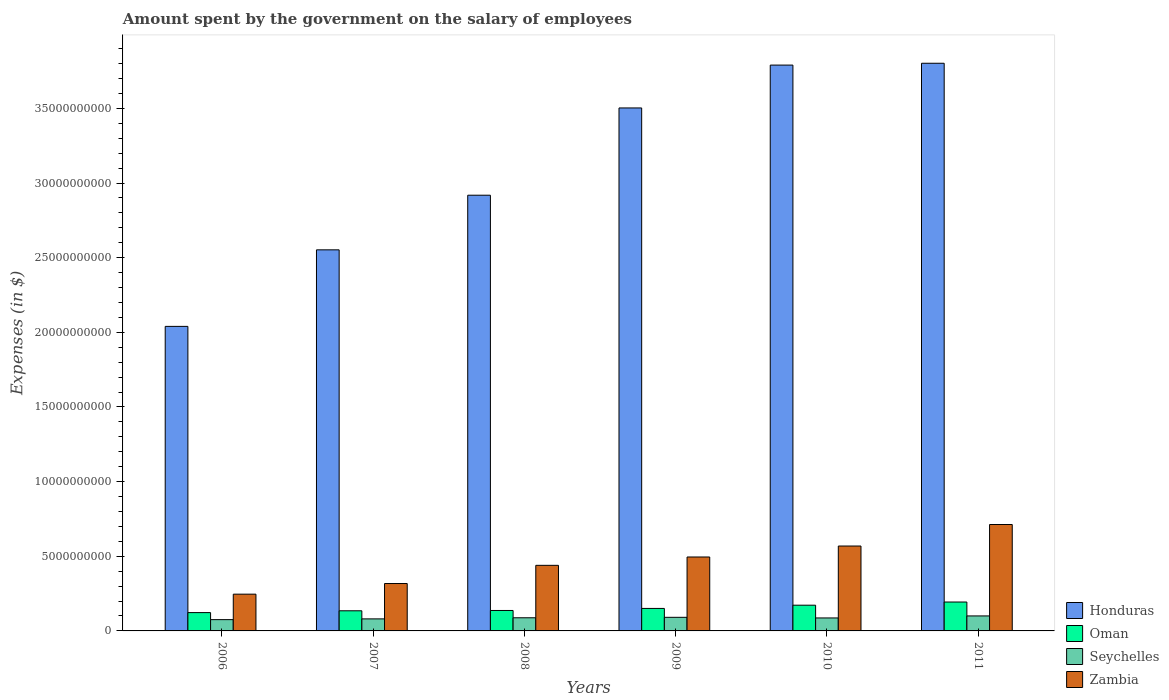How many different coloured bars are there?
Offer a very short reply. 4. Are the number of bars per tick equal to the number of legend labels?
Make the answer very short. Yes. Are the number of bars on each tick of the X-axis equal?
Provide a short and direct response. Yes. What is the amount spent on the salary of employees by the government in Oman in 2007?
Your answer should be compact. 1.35e+09. Across all years, what is the maximum amount spent on the salary of employees by the government in Zambia?
Your response must be concise. 7.13e+09. Across all years, what is the minimum amount spent on the salary of employees by the government in Seychelles?
Provide a short and direct response. 7.56e+08. In which year was the amount spent on the salary of employees by the government in Oman minimum?
Provide a short and direct response. 2006. What is the total amount spent on the salary of employees by the government in Seychelles in the graph?
Keep it short and to the point. 5.23e+09. What is the difference between the amount spent on the salary of employees by the government in Honduras in 2008 and that in 2011?
Keep it short and to the point. -8.84e+09. What is the difference between the amount spent on the salary of employees by the government in Oman in 2007 and the amount spent on the salary of employees by the government in Seychelles in 2010?
Give a very brief answer. 4.79e+08. What is the average amount spent on the salary of employees by the government in Seychelles per year?
Give a very brief answer. 8.71e+08. In the year 2008, what is the difference between the amount spent on the salary of employees by the government in Seychelles and amount spent on the salary of employees by the government in Oman?
Keep it short and to the point. -4.88e+08. What is the ratio of the amount spent on the salary of employees by the government in Zambia in 2008 to that in 2011?
Your answer should be compact. 0.62. Is the difference between the amount spent on the salary of employees by the government in Seychelles in 2009 and 2010 greater than the difference between the amount spent on the salary of employees by the government in Oman in 2009 and 2010?
Keep it short and to the point. Yes. What is the difference between the highest and the second highest amount spent on the salary of employees by the government in Zambia?
Provide a succinct answer. 1.44e+09. What is the difference between the highest and the lowest amount spent on the salary of employees by the government in Oman?
Ensure brevity in your answer.  7.08e+08. In how many years, is the amount spent on the salary of employees by the government in Oman greater than the average amount spent on the salary of employees by the government in Oman taken over all years?
Your answer should be compact. 2. Is it the case that in every year, the sum of the amount spent on the salary of employees by the government in Zambia and amount spent on the salary of employees by the government in Honduras is greater than the sum of amount spent on the salary of employees by the government in Seychelles and amount spent on the salary of employees by the government in Oman?
Your answer should be compact. Yes. What does the 4th bar from the left in 2006 represents?
Make the answer very short. Zambia. What does the 1st bar from the right in 2009 represents?
Keep it short and to the point. Zambia. Is it the case that in every year, the sum of the amount spent on the salary of employees by the government in Honduras and amount spent on the salary of employees by the government in Zambia is greater than the amount spent on the salary of employees by the government in Seychelles?
Offer a very short reply. Yes. Are all the bars in the graph horizontal?
Offer a terse response. No. How many years are there in the graph?
Provide a short and direct response. 6. What is the difference between two consecutive major ticks on the Y-axis?
Provide a short and direct response. 5.00e+09. Does the graph contain grids?
Make the answer very short. No. What is the title of the graph?
Give a very brief answer. Amount spent by the government on the salary of employees. Does "Kyrgyz Republic" appear as one of the legend labels in the graph?
Provide a short and direct response. No. What is the label or title of the Y-axis?
Make the answer very short. Expenses (in $). What is the Expenses (in $) of Honduras in 2006?
Offer a terse response. 2.04e+1. What is the Expenses (in $) of Oman in 2006?
Ensure brevity in your answer.  1.23e+09. What is the Expenses (in $) of Seychelles in 2006?
Keep it short and to the point. 7.56e+08. What is the Expenses (in $) in Zambia in 2006?
Keep it short and to the point. 2.46e+09. What is the Expenses (in $) of Honduras in 2007?
Ensure brevity in your answer.  2.55e+1. What is the Expenses (in $) in Oman in 2007?
Provide a short and direct response. 1.35e+09. What is the Expenses (in $) in Seychelles in 2007?
Your answer should be very brief. 8.06e+08. What is the Expenses (in $) of Zambia in 2007?
Provide a succinct answer. 3.17e+09. What is the Expenses (in $) of Honduras in 2008?
Make the answer very short. 2.92e+1. What is the Expenses (in $) of Oman in 2008?
Your response must be concise. 1.37e+09. What is the Expenses (in $) of Seychelles in 2008?
Your response must be concise. 8.81e+08. What is the Expenses (in $) in Zambia in 2008?
Ensure brevity in your answer.  4.39e+09. What is the Expenses (in $) in Honduras in 2009?
Provide a succinct answer. 3.50e+1. What is the Expenses (in $) of Oman in 2009?
Make the answer very short. 1.51e+09. What is the Expenses (in $) of Seychelles in 2009?
Offer a terse response. 9.11e+08. What is the Expenses (in $) of Zambia in 2009?
Give a very brief answer. 4.95e+09. What is the Expenses (in $) of Honduras in 2010?
Provide a succinct answer. 3.79e+1. What is the Expenses (in $) in Oman in 2010?
Your response must be concise. 1.72e+09. What is the Expenses (in $) of Seychelles in 2010?
Your answer should be very brief. 8.69e+08. What is the Expenses (in $) in Zambia in 2010?
Give a very brief answer. 5.69e+09. What is the Expenses (in $) of Honduras in 2011?
Offer a very short reply. 3.80e+1. What is the Expenses (in $) of Oman in 2011?
Your response must be concise. 1.94e+09. What is the Expenses (in $) of Seychelles in 2011?
Offer a terse response. 1.00e+09. What is the Expenses (in $) of Zambia in 2011?
Give a very brief answer. 7.13e+09. Across all years, what is the maximum Expenses (in $) of Honduras?
Ensure brevity in your answer.  3.80e+1. Across all years, what is the maximum Expenses (in $) of Oman?
Give a very brief answer. 1.94e+09. Across all years, what is the maximum Expenses (in $) in Seychelles?
Your answer should be very brief. 1.00e+09. Across all years, what is the maximum Expenses (in $) of Zambia?
Offer a terse response. 7.13e+09. Across all years, what is the minimum Expenses (in $) in Honduras?
Your answer should be compact. 2.04e+1. Across all years, what is the minimum Expenses (in $) in Oman?
Your response must be concise. 1.23e+09. Across all years, what is the minimum Expenses (in $) of Seychelles?
Give a very brief answer. 7.56e+08. Across all years, what is the minimum Expenses (in $) in Zambia?
Give a very brief answer. 2.46e+09. What is the total Expenses (in $) of Honduras in the graph?
Offer a terse response. 1.86e+11. What is the total Expenses (in $) in Oman in the graph?
Your response must be concise. 9.11e+09. What is the total Expenses (in $) of Seychelles in the graph?
Provide a short and direct response. 5.23e+09. What is the total Expenses (in $) of Zambia in the graph?
Keep it short and to the point. 2.78e+1. What is the difference between the Expenses (in $) in Honduras in 2006 and that in 2007?
Provide a succinct answer. -5.13e+09. What is the difference between the Expenses (in $) in Oman in 2006 and that in 2007?
Provide a short and direct response. -1.20e+08. What is the difference between the Expenses (in $) of Seychelles in 2006 and that in 2007?
Make the answer very short. -4.97e+07. What is the difference between the Expenses (in $) of Zambia in 2006 and that in 2007?
Your answer should be compact. -7.12e+08. What is the difference between the Expenses (in $) of Honduras in 2006 and that in 2008?
Offer a terse response. -8.79e+09. What is the difference between the Expenses (in $) of Oman in 2006 and that in 2008?
Provide a short and direct response. -1.42e+08. What is the difference between the Expenses (in $) of Seychelles in 2006 and that in 2008?
Offer a terse response. -1.25e+08. What is the difference between the Expenses (in $) in Zambia in 2006 and that in 2008?
Your response must be concise. -1.93e+09. What is the difference between the Expenses (in $) of Honduras in 2006 and that in 2009?
Ensure brevity in your answer.  -1.46e+1. What is the difference between the Expenses (in $) in Oman in 2006 and that in 2009?
Provide a succinct answer. -2.79e+08. What is the difference between the Expenses (in $) of Seychelles in 2006 and that in 2009?
Keep it short and to the point. -1.55e+08. What is the difference between the Expenses (in $) in Zambia in 2006 and that in 2009?
Your answer should be compact. -2.49e+09. What is the difference between the Expenses (in $) in Honduras in 2006 and that in 2010?
Keep it short and to the point. -1.75e+1. What is the difference between the Expenses (in $) in Oman in 2006 and that in 2010?
Keep it short and to the point. -4.95e+08. What is the difference between the Expenses (in $) in Seychelles in 2006 and that in 2010?
Keep it short and to the point. -1.12e+08. What is the difference between the Expenses (in $) in Zambia in 2006 and that in 2010?
Your response must be concise. -3.22e+09. What is the difference between the Expenses (in $) of Honduras in 2006 and that in 2011?
Offer a very short reply. -1.76e+1. What is the difference between the Expenses (in $) in Oman in 2006 and that in 2011?
Your response must be concise. -7.08e+08. What is the difference between the Expenses (in $) of Seychelles in 2006 and that in 2011?
Keep it short and to the point. -2.48e+08. What is the difference between the Expenses (in $) of Zambia in 2006 and that in 2011?
Your response must be concise. -4.67e+09. What is the difference between the Expenses (in $) of Honduras in 2007 and that in 2008?
Keep it short and to the point. -3.66e+09. What is the difference between the Expenses (in $) in Oman in 2007 and that in 2008?
Offer a very short reply. -2.13e+07. What is the difference between the Expenses (in $) in Seychelles in 2007 and that in 2008?
Keep it short and to the point. -7.49e+07. What is the difference between the Expenses (in $) of Zambia in 2007 and that in 2008?
Provide a short and direct response. -1.22e+09. What is the difference between the Expenses (in $) of Honduras in 2007 and that in 2009?
Your answer should be very brief. -9.50e+09. What is the difference between the Expenses (in $) of Oman in 2007 and that in 2009?
Provide a short and direct response. -1.59e+08. What is the difference between the Expenses (in $) of Seychelles in 2007 and that in 2009?
Make the answer very short. -1.05e+08. What is the difference between the Expenses (in $) of Zambia in 2007 and that in 2009?
Your answer should be compact. -1.78e+09. What is the difference between the Expenses (in $) of Honduras in 2007 and that in 2010?
Ensure brevity in your answer.  -1.24e+1. What is the difference between the Expenses (in $) in Oman in 2007 and that in 2010?
Provide a succinct answer. -3.75e+08. What is the difference between the Expenses (in $) in Seychelles in 2007 and that in 2010?
Provide a succinct answer. -6.27e+07. What is the difference between the Expenses (in $) in Zambia in 2007 and that in 2010?
Your response must be concise. -2.51e+09. What is the difference between the Expenses (in $) in Honduras in 2007 and that in 2011?
Offer a very short reply. -1.25e+1. What is the difference between the Expenses (in $) in Oman in 2007 and that in 2011?
Keep it short and to the point. -5.88e+08. What is the difference between the Expenses (in $) of Seychelles in 2007 and that in 2011?
Provide a succinct answer. -1.99e+08. What is the difference between the Expenses (in $) of Zambia in 2007 and that in 2011?
Make the answer very short. -3.95e+09. What is the difference between the Expenses (in $) of Honduras in 2008 and that in 2009?
Your response must be concise. -5.85e+09. What is the difference between the Expenses (in $) in Oman in 2008 and that in 2009?
Your answer should be very brief. -1.37e+08. What is the difference between the Expenses (in $) in Seychelles in 2008 and that in 2009?
Keep it short and to the point. -3.04e+07. What is the difference between the Expenses (in $) of Zambia in 2008 and that in 2009?
Provide a short and direct response. -5.59e+08. What is the difference between the Expenses (in $) of Honduras in 2008 and that in 2010?
Keep it short and to the point. -8.72e+09. What is the difference between the Expenses (in $) of Oman in 2008 and that in 2010?
Provide a succinct answer. -3.54e+08. What is the difference between the Expenses (in $) of Seychelles in 2008 and that in 2010?
Provide a succinct answer. 1.22e+07. What is the difference between the Expenses (in $) of Zambia in 2008 and that in 2010?
Provide a short and direct response. -1.29e+09. What is the difference between the Expenses (in $) of Honduras in 2008 and that in 2011?
Keep it short and to the point. -8.84e+09. What is the difference between the Expenses (in $) of Oman in 2008 and that in 2011?
Provide a short and direct response. -5.66e+08. What is the difference between the Expenses (in $) in Seychelles in 2008 and that in 2011?
Offer a very short reply. -1.24e+08. What is the difference between the Expenses (in $) in Zambia in 2008 and that in 2011?
Provide a succinct answer. -2.73e+09. What is the difference between the Expenses (in $) of Honduras in 2009 and that in 2010?
Your response must be concise. -2.87e+09. What is the difference between the Expenses (in $) in Oman in 2009 and that in 2010?
Give a very brief answer. -2.16e+08. What is the difference between the Expenses (in $) in Seychelles in 2009 and that in 2010?
Offer a very short reply. 4.27e+07. What is the difference between the Expenses (in $) of Zambia in 2009 and that in 2010?
Ensure brevity in your answer.  -7.35e+08. What is the difference between the Expenses (in $) in Honduras in 2009 and that in 2011?
Your answer should be very brief. -2.99e+09. What is the difference between the Expenses (in $) of Oman in 2009 and that in 2011?
Give a very brief answer. -4.29e+08. What is the difference between the Expenses (in $) of Seychelles in 2009 and that in 2011?
Your answer should be very brief. -9.33e+07. What is the difference between the Expenses (in $) of Zambia in 2009 and that in 2011?
Your response must be concise. -2.18e+09. What is the difference between the Expenses (in $) in Honduras in 2010 and that in 2011?
Your answer should be very brief. -1.22e+08. What is the difference between the Expenses (in $) in Oman in 2010 and that in 2011?
Offer a terse response. -2.13e+08. What is the difference between the Expenses (in $) in Seychelles in 2010 and that in 2011?
Give a very brief answer. -1.36e+08. What is the difference between the Expenses (in $) of Zambia in 2010 and that in 2011?
Your answer should be very brief. -1.44e+09. What is the difference between the Expenses (in $) of Honduras in 2006 and the Expenses (in $) of Oman in 2007?
Your answer should be compact. 1.90e+1. What is the difference between the Expenses (in $) of Honduras in 2006 and the Expenses (in $) of Seychelles in 2007?
Make the answer very short. 1.96e+1. What is the difference between the Expenses (in $) of Honduras in 2006 and the Expenses (in $) of Zambia in 2007?
Your answer should be compact. 1.72e+1. What is the difference between the Expenses (in $) of Oman in 2006 and the Expenses (in $) of Seychelles in 2007?
Make the answer very short. 4.22e+08. What is the difference between the Expenses (in $) in Oman in 2006 and the Expenses (in $) in Zambia in 2007?
Provide a short and direct response. -1.95e+09. What is the difference between the Expenses (in $) of Seychelles in 2006 and the Expenses (in $) of Zambia in 2007?
Provide a short and direct response. -2.42e+09. What is the difference between the Expenses (in $) of Honduras in 2006 and the Expenses (in $) of Oman in 2008?
Your answer should be compact. 1.90e+1. What is the difference between the Expenses (in $) of Honduras in 2006 and the Expenses (in $) of Seychelles in 2008?
Make the answer very short. 1.95e+1. What is the difference between the Expenses (in $) in Honduras in 2006 and the Expenses (in $) in Zambia in 2008?
Provide a succinct answer. 1.60e+1. What is the difference between the Expenses (in $) of Oman in 2006 and the Expenses (in $) of Seychelles in 2008?
Give a very brief answer. 3.47e+08. What is the difference between the Expenses (in $) in Oman in 2006 and the Expenses (in $) in Zambia in 2008?
Make the answer very short. -3.17e+09. What is the difference between the Expenses (in $) in Seychelles in 2006 and the Expenses (in $) in Zambia in 2008?
Your response must be concise. -3.64e+09. What is the difference between the Expenses (in $) in Honduras in 2006 and the Expenses (in $) in Oman in 2009?
Keep it short and to the point. 1.89e+1. What is the difference between the Expenses (in $) in Honduras in 2006 and the Expenses (in $) in Seychelles in 2009?
Give a very brief answer. 1.95e+1. What is the difference between the Expenses (in $) in Honduras in 2006 and the Expenses (in $) in Zambia in 2009?
Provide a short and direct response. 1.54e+1. What is the difference between the Expenses (in $) in Oman in 2006 and the Expenses (in $) in Seychelles in 2009?
Your answer should be compact. 3.16e+08. What is the difference between the Expenses (in $) in Oman in 2006 and the Expenses (in $) in Zambia in 2009?
Provide a succinct answer. -3.72e+09. What is the difference between the Expenses (in $) of Seychelles in 2006 and the Expenses (in $) of Zambia in 2009?
Your answer should be compact. -4.19e+09. What is the difference between the Expenses (in $) of Honduras in 2006 and the Expenses (in $) of Oman in 2010?
Provide a short and direct response. 1.87e+1. What is the difference between the Expenses (in $) in Honduras in 2006 and the Expenses (in $) in Seychelles in 2010?
Offer a terse response. 1.95e+1. What is the difference between the Expenses (in $) in Honduras in 2006 and the Expenses (in $) in Zambia in 2010?
Offer a terse response. 1.47e+1. What is the difference between the Expenses (in $) in Oman in 2006 and the Expenses (in $) in Seychelles in 2010?
Give a very brief answer. 3.59e+08. What is the difference between the Expenses (in $) in Oman in 2006 and the Expenses (in $) in Zambia in 2010?
Offer a terse response. -4.46e+09. What is the difference between the Expenses (in $) of Seychelles in 2006 and the Expenses (in $) of Zambia in 2010?
Keep it short and to the point. -4.93e+09. What is the difference between the Expenses (in $) in Honduras in 2006 and the Expenses (in $) in Oman in 2011?
Give a very brief answer. 1.85e+1. What is the difference between the Expenses (in $) of Honduras in 2006 and the Expenses (in $) of Seychelles in 2011?
Provide a succinct answer. 1.94e+1. What is the difference between the Expenses (in $) of Honduras in 2006 and the Expenses (in $) of Zambia in 2011?
Your answer should be very brief. 1.33e+1. What is the difference between the Expenses (in $) in Oman in 2006 and the Expenses (in $) in Seychelles in 2011?
Offer a very short reply. 2.23e+08. What is the difference between the Expenses (in $) in Oman in 2006 and the Expenses (in $) in Zambia in 2011?
Your response must be concise. -5.90e+09. What is the difference between the Expenses (in $) of Seychelles in 2006 and the Expenses (in $) of Zambia in 2011?
Your answer should be very brief. -6.37e+09. What is the difference between the Expenses (in $) in Honduras in 2007 and the Expenses (in $) in Oman in 2008?
Offer a very short reply. 2.42e+1. What is the difference between the Expenses (in $) of Honduras in 2007 and the Expenses (in $) of Seychelles in 2008?
Your answer should be compact. 2.46e+1. What is the difference between the Expenses (in $) of Honduras in 2007 and the Expenses (in $) of Zambia in 2008?
Ensure brevity in your answer.  2.11e+1. What is the difference between the Expenses (in $) in Oman in 2007 and the Expenses (in $) in Seychelles in 2008?
Ensure brevity in your answer.  4.67e+08. What is the difference between the Expenses (in $) of Oman in 2007 and the Expenses (in $) of Zambia in 2008?
Ensure brevity in your answer.  -3.04e+09. What is the difference between the Expenses (in $) of Seychelles in 2007 and the Expenses (in $) of Zambia in 2008?
Provide a short and direct response. -3.59e+09. What is the difference between the Expenses (in $) in Honduras in 2007 and the Expenses (in $) in Oman in 2009?
Your response must be concise. 2.40e+1. What is the difference between the Expenses (in $) in Honduras in 2007 and the Expenses (in $) in Seychelles in 2009?
Make the answer very short. 2.46e+1. What is the difference between the Expenses (in $) of Honduras in 2007 and the Expenses (in $) of Zambia in 2009?
Keep it short and to the point. 2.06e+1. What is the difference between the Expenses (in $) of Oman in 2007 and the Expenses (in $) of Seychelles in 2009?
Your response must be concise. 4.37e+08. What is the difference between the Expenses (in $) of Oman in 2007 and the Expenses (in $) of Zambia in 2009?
Make the answer very short. -3.60e+09. What is the difference between the Expenses (in $) of Seychelles in 2007 and the Expenses (in $) of Zambia in 2009?
Provide a succinct answer. -4.15e+09. What is the difference between the Expenses (in $) of Honduras in 2007 and the Expenses (in $) of Oman in 2010?
Offer a very short reply. 2.38e+1. What is the difference between the Expenses (in $) in Honduras in 2007 and the Expenses (in $) in Seychelles in 2010?
Make the answer very short. 2.47e+1. What is the difference between the Expenses (in $) of Honduras in 2007 and the Expenses (in $) of Zambia in 2010?
Keep it short and to the point. 1.98e+1. What is the difference between the Expenses (in $) of Oman in 2007 and the Expenses (in $) of Seychelles in 2010?
Offer a very short reply. 4.79e+08. What is the difference between the Expenses (in $) in Oman in 2007 and the Expenses (in $) in Zambia in 2010?
Ensure brevity in your answer.  -4.34e+09. What is the difference between the Expenses (in $) of Seychelles in 2007 and the Expenses (in $) of Zambia in 2010?
Give a very brief answer. -4.88e+09. What is the difference between the Expenses (in $) in Honduras in 2007 and the Expenses (in $) in Oman in 2011?
Your response must be concise. 2.36e+1. What is the difference between the Expenses (in $) of Honduras in 2007 and the Expenses (in $) of Seychelles in 2011?
Your response must be concise. 2.45e+1. What is the difference between the Expenses (in $) in Honduras in 2007 and the Expenses (in $) in Zambia in 2011?
Offer a terse response. 1.84e+1. What is the difference between the Expenses (in $) in Oman in 2007 and the Expenses (in $) in Seychelles in 2011?
Your response must be concise. 3.43e+08. What is the difference between the Expenses (in $) in Oman in 2007 and the Expenses (in $) in Zambia in 2011?
Your answer should be very brief. -5.78e+09. What is the difference between the Expenses (in $) of Seychelles in 2007 and the Expenses (in $) of Zambia in 2011?
Your answer should be very brief. -6.32e+09. What is the difference between the Expenses (in $) of Honduras in 2008 and the Expenses (in $) of Oman in 2009?
Keep it short and to the point. 2.77e+1. What is the difference between the Expenses (in $) in Honduras in 2008 and the Expenses (in $) in Seychelles in 2009?
Keep it short and to the point. 2.83e+1. What is the difference between the Expenses (in $) in Honduras in 2008 and the Expenses (in $) in Zambia in 2009?
Make the answer very short. 2.42e+1. What is the difference between the Expenses (in $) of Oman in 2008 and the Expenses (in $) of Seychelles in 2009?
Ensure brevity in your answer.  4.58e+08. What is the difference between the Expenses (in $) in Oman in 2008 and the Expenses (in $) in Zambia in 2009?
Ensure brevity in your answer.  -3.58e+09. What is the difference between the Expenses (in $) of Seychelles in 2008 and the Expenses (in $) of Zambia in 2009?
Provide a succinct answer. -4.07e+09. What is the difference between the Expenses (in $) of Honduras in 2008 and the Expenses (in $) of Oman in 2010?
Your response must be concise. 2.75e+1. What is the difference between the Expenses (in $) in Honduras in 2008 and the Expenses (in $) in Seychelles in 2010?
Offer a terse response. 2.83e+1. What is the difference between the Expenses (in $) of Honduras in 2008 and the Expenses (in $) of Zambia in 2010?
Provide a succinct answer. 2.35e+1. What is the difference between the Expenses (in $) of Oman in 2008 and the Expenses (in $) of Seychelles in 2010?
Keep it short and to the point. 5.01e+08. What is the difference between the Expenses (in $) in Oman in 2008 and the Expenses (in $) in Zambia in 2010?
Give a very brief answer. -4.32e+09. What is the difference between the Expenses (in $) of Seychelles in 2008 and the Expenses (in $) of Zambia in 2010?
Your response must be concise. -4.81e+09. What is the difference between the Expenses (in $) in Honduras in 2008 and the Expenses (in $) in Oman in 2011?
Ensure brevity in your answer.  2.72e+1. What is the difference between the Expenses (in $) of Honduras in 2008 and the Expenses (in $) of Seychelles in 2011?
Provide a succinct answer. 2.82e+1. What is the difference between the Expenses (in $) in Honduras in 2008 and the Expenses (in $) in Zambia in 2011?
Your answer should be compact. 2.21e+1. What is the difference between the Expenses (in $) in Oman in 2008 and the Expenses (in $) in Seychelles in 2011?
Offer a very short reply. 3.65e+08. What is the difference between the Expenses (in $) of Oman in 2008 and the Expenses (in $) of Zambia in 2011?
Provide a succinct answer. -5.76e+09. What is the difference between the Expenses (in $) of Seychelles in 2008 and the Expenses (in $) of Zambia in 2011?
Provide a short and direct response. -6.25e+09. What is the difference between the Expenses (in $) in Honduras in 2009 and the Expenses (in $) in Oman in 2010?
Your answer should be compact. 3.33e+1. What is the difference between the Expenses (in $) in Honduras in 2009 and the Expenses (in $) in Seychelles in 2010?
Your answer should be very brief. 3.42e+1. What is the difference between the Expenses (in $) in Honduras in 2009 and the Expenses (in $) in Zambia in 2010?
Ensure brevity in your answer.  2.93e+1. What is the difference between the Expenses (in $) in Oman in 2009 and the Expenses (in $) in Seychelles in 2010?
Your answer should be compact. 6.38e+08. What is the difference between the Expenses (in $) in Oman in 2009 and the Expenses (in $) in Zambia in 2010?
Your response must be concise. -4.18e+09. What is the difference between the Expenses (in $) in Seychelles in 2009 and the Expenses (in $) in Zambia in 2010?
Ensure brevity in your answer.  -4.77e+09. What is the difference between the Expenses (in $) of Honduras in 2009 and the Expenses (in $) of Oman in 2011?
Your response must be concise. 3.31e+1. What is the difference between the Expenses (in $) in Honduras in 2009 and the Expenses (in $) in Seychelles in 2011?
Keep it short and to the point. 3.40e+1. What is the difference between the Expenses (in $) of Honduras in 2009 and the Expenses (in $) of Zambia in 2011?
Provide a short and direct response. 2.79e+1. What is the difference between the Expenses (in $) in Oman in 2009 and the Expenses (in $) in Seychelles in 2011?
Your answer should be compact. 5.02e+08. What is the difference between the Expenses (in $) of Oman in 2009 and the Expenses (in $) of Zambia in 2011?
Make the answer very short. -5.62e+09. What is the difference between the Expenses (in $) of Seychelles in 2009 and the Expenses (in $) of Zambia in 2011?
Offer a very short reply. -6.22e+09. What is the difference between the Expenses (in $) in Honduras in 2010 and the Expenses (in $) in Oman in 2011?
Keep it short and to the point. 3.60e+1. What is the difference between the Expenses (in $) in Honduras in 2010 and the Expenses (in $) in Seychelles in 2011?
Provide a short and direct response. 3.69e+1. What is the difference between the Expenses (in $) of Honduras in 2010 and the Expenses (in $) of Zambia in 2011?
Make the answer very short. 3.08e+1. What is the difference between the Expenses (in $) in Oman in 2010 and the Expenses (in $) in Seychelles in 2011?
Make the answer very short. 7.18e+08. What is the difference between the Expenses (in $) in Oman in 2010 and the Expenses (in $) in Zambia in 2011?
Provide a succinct answer. -5.40e+09. What is the difference between the Expenses (in $) of Seychelles in 2010 and the Expenses (in $) of Zambia in 2011?
Provide a short and direct response. -6.26e+09. What is the average Expenses (in $) in Honduras per year?
Your answer should be very brief. 3.10e+1. What is the average Expenses (in $) in Oman per year?
Ensure brevity in your answer.  1.52e+09. What is the average Expenses (in $) of Seychelles per year?
Offer a very short reply. 8.71e+08. What is the average Expenses (in $) in Zambia per year?
Your answer should be very brief. 4.63e+09. In the year 2006, what is the difference between the Expenses (in $) in Honduras and Expenses (in $) in Oman?
Your response must be concise. 1.92e+1. In the year 2006, what is the difference between the Expenses (in $) in Honduras and Expenses (in $) in Seychelles?
Offer a very short reply. 1.96e+1. In the year 2006, what is the difference between the Expenses (in $) of Honduras and Expenses (in $) of Zambia?
Your answer should be very brief. 1.79e+1. In the year 2006, what is the difference between the Expenses (in $) of Oman and Expenses (in $) of Seychelles?
Keep it short and to the point. 4.71e+08. In the year 2006, what is the difference between the Expenses (in $) of Oman and Expenses (in $) of Zambia?
Your answer should be compact. -1.23e+09. In the year 2006, what is the difference between the Expenses (in $) of Seychelles and Expenses (in $) of Zambia?
Offer a very short reply. -1.71e+09. In the year 2007, what is the difference between the Expenses (in $) in Honduras and Expenses (in $) in Oman?
Keep it short and to the point. 2.42e+1. In the year 2007, what is the difference between the Expenses (in $) in Honduras and Expenses (in $) in Seychelles?
Your response must be concise. 2.47e+1. In the year 2007, what is the difference between the Expenses (in $) of Honduras and Expenses (in $) of Zambia?
Ensure brevity in your answer.  2.23e+1. In the year 2007, what is the difference between the Expenses (in $) in Oman and Expenses (in $) in Seychelles?
Provide a succinct answer. 5.42e+08. In the year 2007, what is the difference between the Expenses (in $) of Oman and Expenses (in $) of Zambia?
Your response must be concise. -1.83e+09. In the year 2007, what is the difference between the Expenses (in $) of Seychelles and Expenses (in $) of Zambia?
Make the answer very short. -2.37e+09. In the year 2008, what is the difference between the Expenses (in $) of Honduras and Expenses (in $) of Oman?
Make the answer very short. 2.78e+1. In the year 2008, what is the difference between the Expenses (in $) of Honduras and Expenses (in $) of Seychelles?
Keep it short and to the point. 2.83e+1. In the year 2008, what is the difference between the Expenses (in $) of Honduras and Expenses (in $) of Zambia?
Provide a succinct answer. 2.48e+1. In the year 2008, what is the difference between the Expenses (in $) of Oman and Expenses (in $) of Seychelles?
Offer a very short reply. 4.88e+08. In the year 2008, what is the difference between the Expenses (in $) in Oman and Expenses (in $) in Zambia?
Your response must be concise. -3.02e+09. In the year 2008, what is the difference between the Expenses (in $) of Seychelles and Expenses (in $) of Zambia?
Your answer should be very brief. -3.51e+09. In the year 2009, what is the difference between the Expenses (in $) in Honduras and Expenses (in $) in Oman?
Your answer should be compact. 3.35e+1. In the year 2009, what is the difference between the Expenses (in $) in Honduras and Expenses (in $) in Seychelles?
Give a very brief answer. 3.41e+1. In the year 2009, what is the difference between the Expenses (in $) in Honduras and Expenses (in $) in Zambia?
Your answer should be compact. 3.01e+1. In the year 2009, what is the difference between the Expenses (in $) in Oman and Expenses (in $) in Seychelles?
Your answer should be compact. 5.95e+08. In the year 2009, what is the difference between the Expenses (in $) of Oman and Expenses (in $) of Zambia?
Ensure brevity in your answer.  -3.44e+09. In the year 2009, what is the difference between the Expenses (in $) in Seychelles and Expenses (in $) in Zambia?
Offer a very short reply. -4.04e+09. In the year 2010, what is the difference between the Expenses (in $) of Honduras and Expenses (in $) of Oman?
Your answer should be compact. 3.62e+1. In the year 2010, what is the difference between the Expenses (in $) in Honduras and Expenses (in $) in Seychelles?
Give a very brief answer. 3.70e+1. In the year 2010, what is the difference between the Expenses (in $) of Honduras and Expenses (in $) of Zambia?
Offer a very short reply. 3.22e+1. In the year 2010, what is the difference between the Expenses (in $) of Oman and Expenses (in $) of Seychelles?
Your answer should be compact. 8.54e+08. In the year 2010, what is the difference between the Expenses (in $) in Oman and Expenses (in $) in Zambia?
Provide a short and direct response. -3.96e+09. In the year 2010, what is the difference between the Expenses (in $) in Seychelles and Expenses (in $) in Zambia?
Provide a succinct answer. -4.82e+09. In the year 2011, what is the difference between the Expenses (in $) of Honduras and Expenses (in $) of Oman?
Your answer should be compact. 3.61e+1. In the year 2011, what is the difference between the Expenses (in $) in Honduras and Expenses (in $) in Seychelles?
Make the answer very short. 3.70e+1. In the year 2011, what is the difference between the Expenses (in $) of Honduras and Expenses (in $) of Zambia?
Make the answer very short. 3.09e+1. In the year 2011, what is the difference between the Expenses (in $) of Oman and Expenses (in $) of Seychelles?
Your answer should be very brief. 9.31e+08. In the year 2011, what is the difference between the Expenses (in $) of Oman and Expenses (in $) of Zambia?
Provide a succinct answer. -5.19e+09. In the year 2011, what is the difference between the Expenses (in $) in Seychelles and Expenses (in $) in Zambia?
Offer a very short reply. -6.12e+09. What is the ratio of the Expenses (in $) of Honduras in 2006 to that in 2007?
Ensure brevity in your answer.  0.8. What is the ratio of the Expenses (in $) in Oman in 2006 to that in 2007?
Offer a very short reply. 0.91. What is the ratio of the Expenses (in $) in Seychelles in 2006 to that in 2007?
Give a very brief answer. 0.94. What is the ratio of the Expenses (in $) in Zambia in 2006 to that in 2007?
Make the answer very short. 0.78. What is the ratio of the Expenses (in $) in Honduras in 2006 to that in 2008?
Your answer should be very brief. 0.7. What is the ratio of the Expenses (in $) in Oman in 2006 to that in 2008?
Provide a short and direct response. 0.9. What is the ratio of the Expenses (in $) in Seychelles in 2006 to that in 2008?
Your answer should be compact. 0.86. What is the ratio of the Expenses (in $) in Zambia in 2006 to that in 2008?
Your response must be concise. 0.56. What is the ratio of the Expenses (in $) in Honduras in 2006 to that in 2009?
Provide a short and direct response. 0.58. What is the ratio of the Expenses (in $) in Oman in 2006 to that in 2009?
Your answer should be compact. 0.81. What is the ratio of the Expenses (in $) of Seychelles in 2006 to that in 2009?
Make the answer very short. 0.83. What is the ratio of the Expenses (in $) in Zambia in 2006 to that in 2009?
Provide a short and direct response. 0.5. What is the ratio of the Expenses (in $) of Honduras in 2006 to that in 2010?
Your response must be concise. 0.54. What is the ratio of the Expenses (in $) of Oman in 2006 to that in 2010?
Provide a succinct answer. 0.71. What is the ratio of the Expenses (in $) of Seychelles in 2006 to that in 2010?
Provide a short and direct response. 0.87. What is the ratio of the Expenses (in $) of Zambia in 2006 to that in 2010?
Provide a succinct answer. 0.43. What is the ratio of the Expenses (in $) in Honduras in 2006 to that in 2011?
Make the answer very short. 0.54. What is the ratio of the Expenses (in $) of Oman in 2006 to that in 2011?
Provide a short and direct response. 0.63. What is the ratio of the Expenses (in $) of Seychelles in 2006 to that in 2011?
Ensure brevity in your answer.  0.75. What is the ratio of the Expenses (in $) of Zambia in 2006 to that in 2011?
Your answer should be compact. 0.35. What is the ratio of the Expenses (in $) of Honduras in 2007 to that in 2008?
Your answer should be very brief. 0.87. What is the ratio of the Expenses (in $) of Oman in 2007 to that in 2008?
Make the answer very short. 0.98. What is the ratio of the Expenses (in $) of Seychelles in 2007 to that in 2008?
Provide a short and direct response. 0.91. What is the ratio of the Expenses (in $) of Zambia in 2007 to that in 2008?
Ensure brevity in your answer.  0.72. What is the ratio of the Expenses (in $) in Honduras in 2007 to that in 2009?
Provide a succinct answer. 0.73. What is the ratio of the Expenses (in $) of Oman in 2007 to that in 2009?
Your answer should be very brief. 0.89. What is the ratio of the Expenses (in $) in Seychelles in 2007 to that in 2009?
Give a very brief answer. 0.88. What is the ratio of the Expenses (in $) in Zambia in 2007 to that in 2009?
Offer a very short reply. 0.64. What is the ratio of the Expenses (in $) in Honduras in 2007 to that in 2010?
Offer a very short reply. 0.67. What is the ratio of the Expenses (in $) of Oman in 2007 to that in 2010?
Make the answer very short. 0.78. What is the ratio of the Expenses (in $) of Seychelles in 2007 to that in 2010?
Your response must be concise. 0.93. What is the ratio of the Expenses (in $) of Zambia in 2007 to that in 2010?
Offer a terse response. 0.56. What is the ratio of the Expenses (in $) of Honduras in 2007 to that in 2011?
Ensure brevity in your answer.  0.67. What is the ratio of the Expenses (in $) of Oman in 2007 to that in 2011?
Provide a succinct answer. 0.7. What is the ratio of the Expenses (in $) in Seychelles in 2007 to that in 2011?
Your answer should be very brief. 0.8. What is the ratio of the Expenses (in $) in Zambia in 2007 to that in 2011?
Give a very brief answer. 0.45. What is the ratio of the Expenses (in $) of Honduras in 2008 to that in 2009?
Provide a succinct answer. 0.83. What is the ratio of the Expenses (in $) of Oman in 2008 to that in 2009?
Give a very brief answer. 0.91. What is the ratio of the Expenses (in $) in Seychelles in 2008 to that in 2009?
Make the answer very short. 0.97. What is the ratio of the Expenses (in $) in Zambia in 2008 to that in 2009?
Provide a succinct answer. 0.89. What is the ratio of the Expenses (in $) of Honduras in 2008 to that in 2010?
Your response must be concise. 0.77. What is the ratio of the Expenses (in $) of Oman in 2008 to that in 2010?
Provide a short and direct response. 0.79. What is the ratio of the Expenses (in $) in Seychelles in 2008 to that in 2010?
Ensure brevity in your answer.  1.01. What is the ratio of the Expenses (in $) of Zambia in 2008 to that in 2010?
Offer a terse response. 0.77. What is the ratio of the Expenses (in $) in Honduras in 2008 to that in 2011?
Give a very brief answer. 0.77. What is the ratio of the Expenses (in $) in Oman in 2008 to that in 2011?
Offer a very short reply. 0.71. What is the ratio of the Expenses (in $) in Seychelles in 2008 to that in 2011?
Make the answer very short. 0.88. What is the ratio of the Expenses (in $) of Zambia in 2008 to that in 2011?
Offer a terse response. 0.62. What is the ratio of the Expenses (in $) in Honduras in 2009 to that in 2010?
Keep it short and to the point. 0.92. What is the ratio of the Expenses (in $) in Oman in 2009 to that in 2010?
Offer a very short reply. 0.87. What is the ratio of the Expenses (in $) in Seychelles in 2009 to that in 2010?
Your response must be concise. 1.05. What is the ratio of the Expenses (in $) of Zambia in 2009 to that in 2010?
Offer a very short reply. 0.87. What is the ratio of the Expenses (in $) of Honduras in 2009 to that in 2011?
Ensure brevity in your answer.  0.92. What is the ratio of the Expenses (in $) of Oman in 2009 to that in 2011?
Give a very brief answer. 0.78. What is the ratio of the Expenses (in $) in Seychelles in 2009 to that in 2011?
Provide a short and direct response. 0.91. What is the ratio of the Expenses (in $) of Zambia in 2009 to that in 2011?
Give a very brief answer. 0.69. What is the ratio of the Expenses (in $) in Honduras in 2010 to that in 2011?
Your answer should be very brief. 1. What is the ratio of the Expenses (in $) of Oman in 2010 to that in 2011?
Offer a terse response. 0.89. What is the ratio of the Expenses (in $) in Seychelles in 2010 to that in 2011?
Make the answer very short. 0.86. What is the ratio of the Expenses (in $) in Zambia in 2010 to that in 2011?
Your answer should be very brief. 0.8. What is the difference between the highest and the second highest Expenses (in $) in Honduras?
Provide a succinct answer. 1.22e+08. What is the difference between the highest and the second highest Expenses (in $) of Oman?
Your answer should be compact. 2.13e+08. What is the difference between the highest and the second highest Expenses (in $) in Seychelles?
Give a very brief answer. 9.33e+07. What is the difference between the highest and the second highest Expenses (in $) of Zambia?
Ensure brevity in your answer.  1.44e+09. What is the difference between the highest and the lowest Expenses (in $) in Honduras?
Your response must be concise. 1.76e+1. What is the difference between the highest and the lowest Expenses (in $) in Oman?
Offer a very short reply. 7.08e+08. What is the difference between the highest and the lowest Expenses (in $) of Seychelles?
Provide a succinct answer. 2.48e+08. What is the difference between the highest and the lowest Expenses (in $) of Zambia?
Your answer should be very brief. 4.67e+09. 